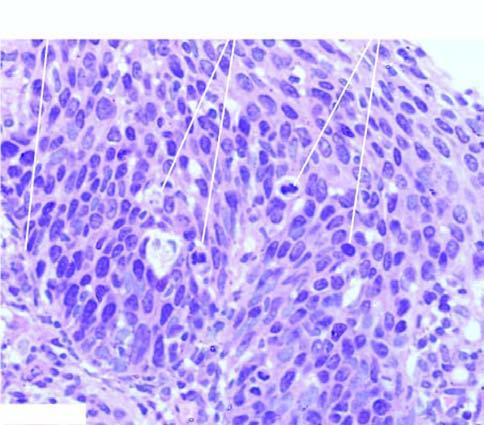re the atypical dysplastic squamous cells confined to all the layers of the mucosa but the basement membrane on which these layers rest is intact?
Answer the question using a single word or phrase. Yes 